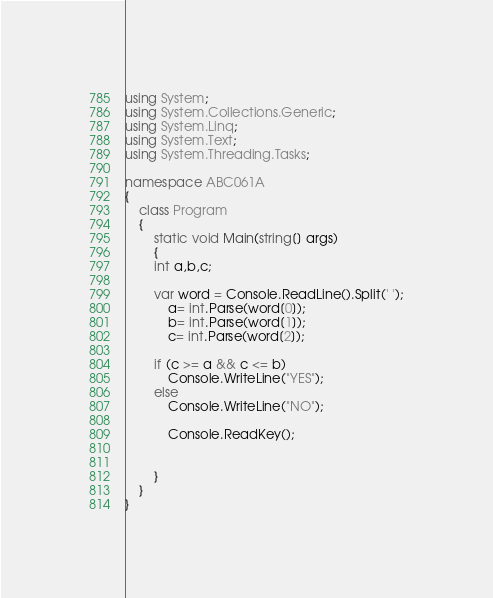Convert code to text. <code><loc_0><loc_0><loc_500><loc_500><_C#_>using System;
using System.Collections.Generic;
using System.Linq;
using System.Text;
using System.Threading.Tasks;

namespace ABC061A
{
	class Program
	{
		static void Main(string[] args)
		{
		int a,b,c;

		var word = Console.ReadLine().Split(' ');
			a= int.Parse(word[0]);
			b= int.Parse(word[1]);
			c= int.Parse(word[2]);

		if (c >= a && c <= b)
			Console.WriteLine("YES");
		else
			Console.WriteLine("NO");

			Console.ReadKey();

			
		}
	}
}</code> 